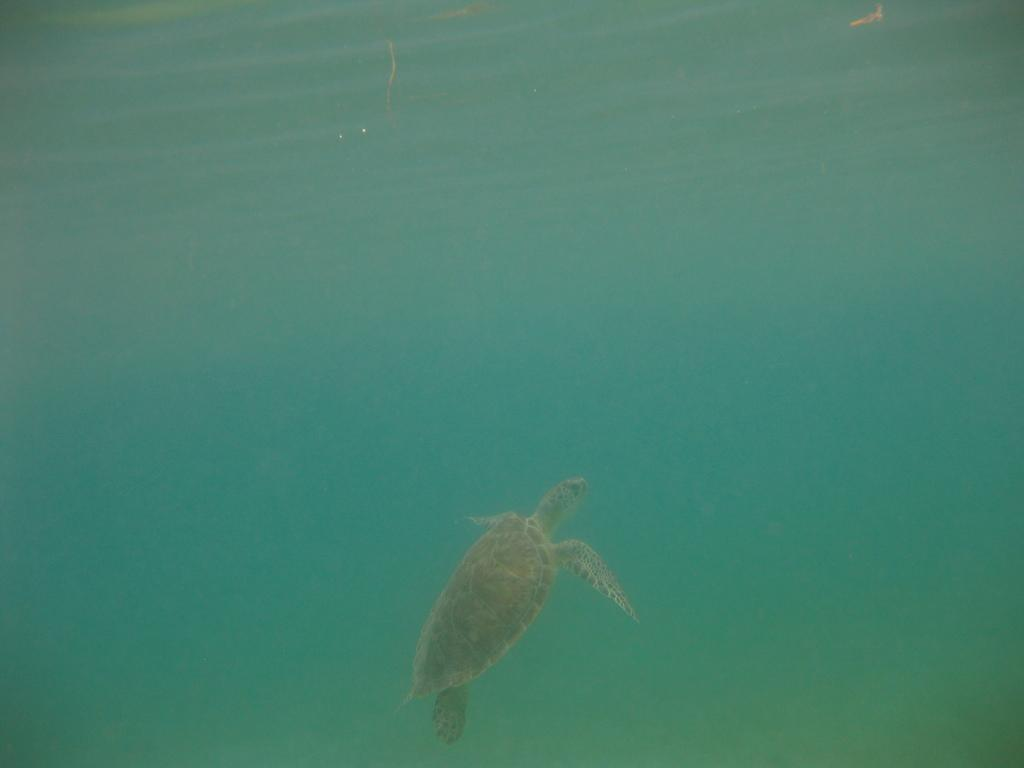What animal is present in the image? There is a tortoise in the image. Where is the tortoise located? The tortoise is in the water. What type of tin can be seen floating next to the tortoise in the image? There is no tin present in the image; it only features a tortoise in the water. 